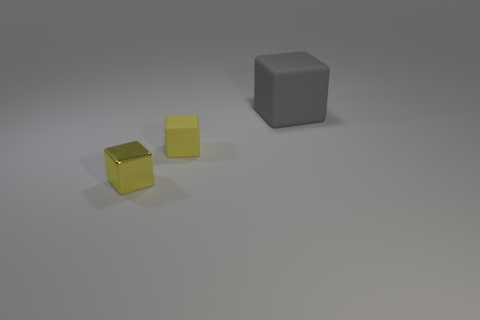What size is the cube that is the same color as the metallic object?
Offer a terse response. Small. What number of other objects are there of the same shape as the large matte object?
Keep it short and to the point. 2. There is a matte cube that is left of the big gray rubber block; are there any blocks that are on the left side of it?
Ensure brevity in your answer.  Yes. How many metallic cubes are there?
Offer a very short reply. 1. Do the big object and the rubber block that is to the left of the big cube have the same color?
Make the answer very short. No. Is the number of large gray matte things greater than the number of yellow rubber cylinders?
Keep it short and to the point. Yes. Are there any other things that have the same color as the tiny matte thing?
Your answer should be very brief. Yes. How many other objects are the same size as the yellow shiny object?
Your answer should be compact. 1. What material is the yellow object that is on the right side of the tiny block that is to the left of the small block that is behind the shiny object?
Ensure brevity in your answer.  Rubber. Does the gray block have the same material as the yellow cube that is in front of the tiny yellow rubber object?
Provide a short and direct response. No. 